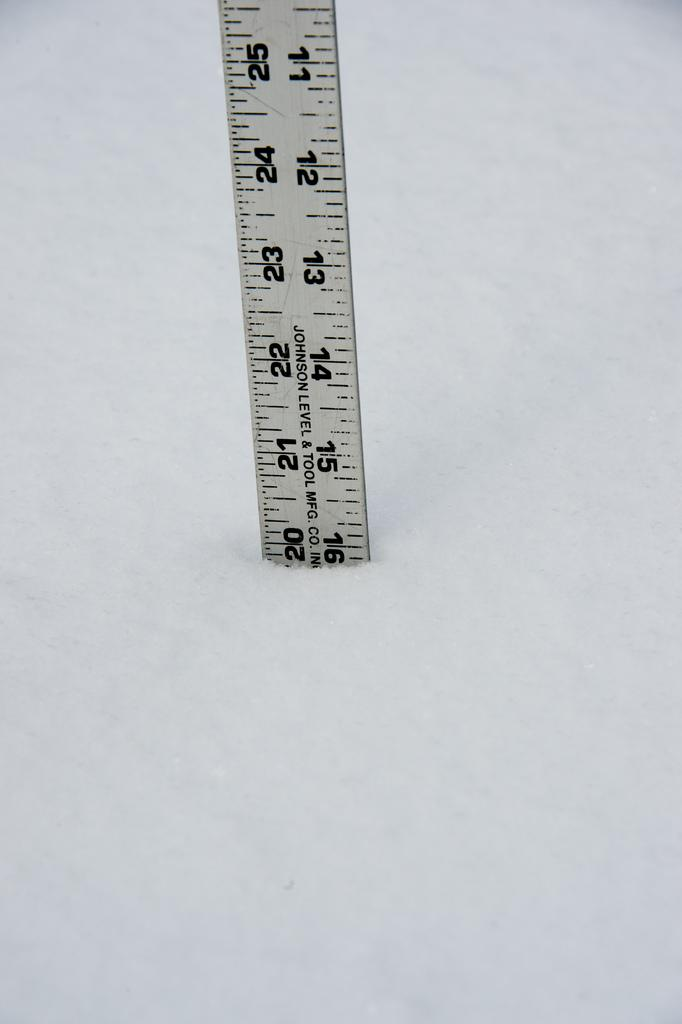Provide a one-sentence caption for the provided image. A ruler made by Johnson Level & Tool Mfg. company. 